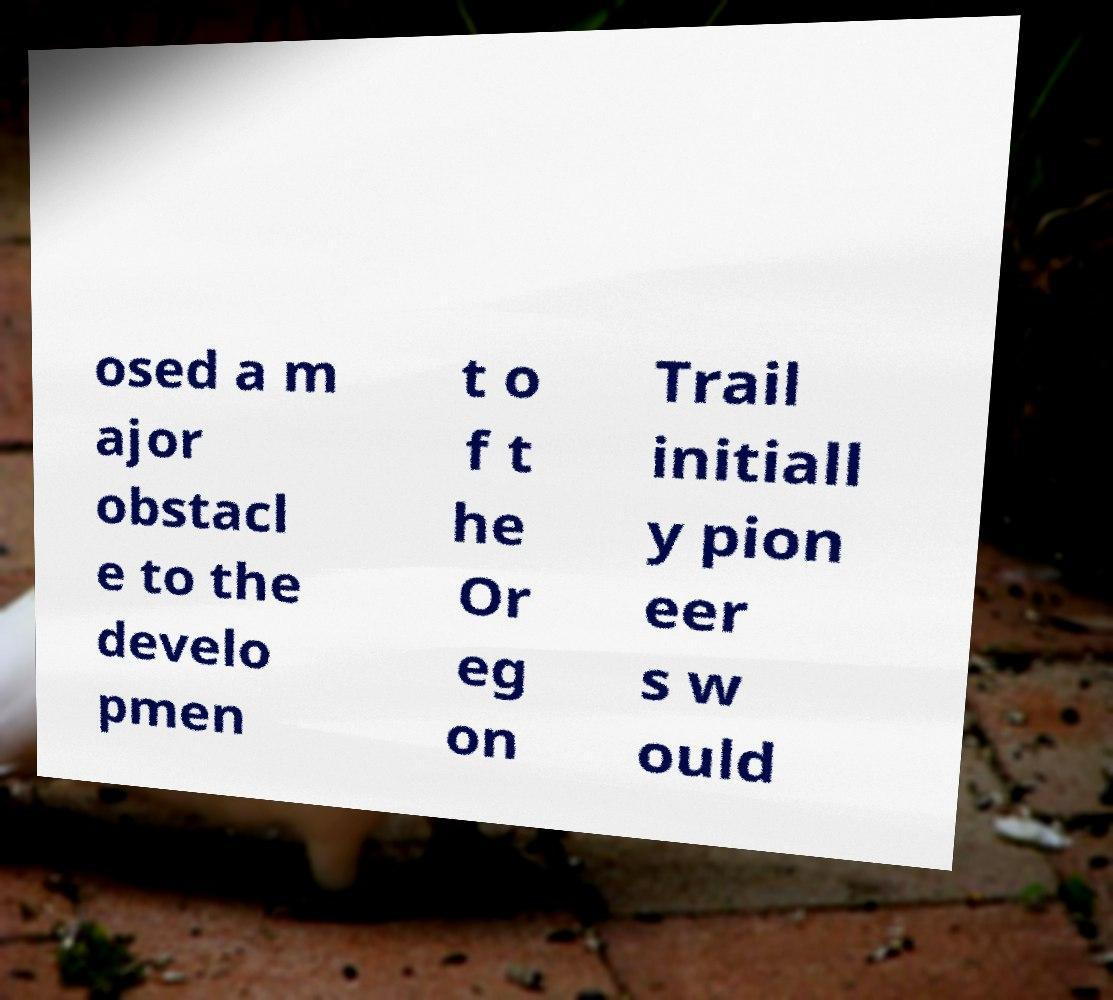I need the written content from this picture converted into text. Can you do that? osed a m ajor obstacl e to the develo pmen t o f t he Or eg on Trail initiall y pion eer s w ould 